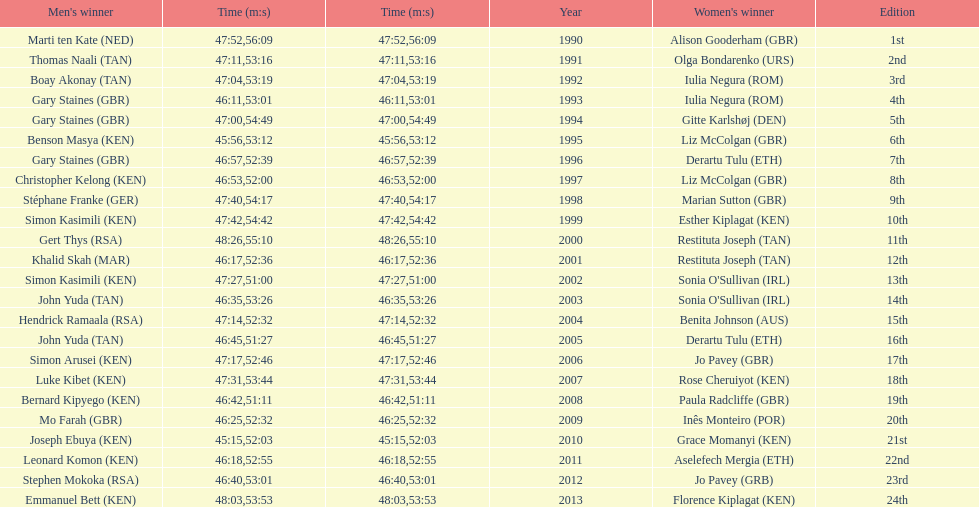Could you help me parse every detail presented in this table? {'header': ["Men's winner", 'Time (m:s)', 'Time (m:s)', 'Year', "Women's winner", 'Edition'], 'rows': [['Marti ten Kate\xa0(NED)', '47:52', '56:09', '1990', 'Alison Gooderham\xa0(GBR)', '1st'], ['Thomas Naali\xa0(TAN)', '47:11', '53:16', '1991', 'Olga Bondarenko\xa0(URS)', '2nd'], ['Boay Akonay\xa0(TAN)', '47:04', '53:19', '1992', 'Iulia Negura\xa0(ROM)', '3rd'], ['Gary Staines\xa0(GBR)', '46:11', '53:01', '1993', 'Iulia Negura\xa0(ROM)', '4th'], ['Gary Staines\xa0(GBR)', '47:00', '54:49', '1994', 'Gitte Karlshøj\xa0(DEN)', '5th'], ['Benson Masya\xa0(KEN)', '45:56', '53:12', '1995', 'Liz McColgan\xa0(GBR)', '6th'], ['Gary Staines\xa0(GBR)', '46:57', '52:39', '1996', 'Derartu Tulu\xa0(ETH)', '7th'], ['Christopher Kelong\xa0(KEN)', '46:53', '52:00', '1997', 'Liz McColgan\xa0(GBR)', '8th'], ['Stéphane Franke\xa0(GER)', '47:40', '54:17', '1998', 'Marian Sutton\xa0(GBR)', '9th'], ['Simon Kasimili\xa0(KEN)', '47:42', '54:42', '1999', 'Esther Kiplagat\xa0(KEN)', '10th'], ['Gert Thys\xa0(RSA)', '48:26', '55:10', '2000', 'Restituta Joseph\xa0(TAN)', '11th'], ['Khalid Skah\xa0(MAR)', '46:17', '52:36', '2001', 'Restituta Joseph\xa0(TAN)', '12th'], ['Simon Kasimili\xa0(KEN)', '47:27', '51:00', '2002', "Sonia O'Sullivan\xa0(IRL)", '13th'], ['John Yuda\xa0(TAN)', '46:35', '53:26', '2003', "Sonia O'Sullivan\xa0(IRL)", '14th'], ['Hendrick Ramaala\xa0(RSA)', '47:14', '52:32', '2004', 'Benita Johnson\xa0(AUS)', '15th'], ['John Yuda\xa0(TAN)', '46:45', '51:27', '2005', 'Derartu Tulu\xa0(ETH)', '16th'], ['Simon Arusei\xa0(KEN)', '47:17', '52:46', '2006', 'Jo Pavey\xa0(GBR)', '17th'], ['Luke Kibet\xa0(KEN)', '47:31', '53:44', '2007', 'Rose Cheruiyot\xa0(KEN)', '18th'], ['Bernard Kipyego\xa0(KEN)', '46:42', '51:11', '2008', 'Paula Radcliffe\xa0(GBR)', '19th'], ['Mo Farah\xa0(GBR)', '46:25', '52:32', '2009', 'Inês Monteiro\xa0(POR)', '20th'], ['Joseph Ebuya\xa0(KEN)', '45:15', '52:03', '2010', 'Grace Momanyi\xa0(KEN)', '21st'], ['Leonard Komon\xa0(KEN)', '46:18', '52:55', '2011', 'Aselefech Mergia\xa0(ETH)', '22nd'], ['Stephen Mokoka\xa0(RSA)', '46:40', '53:01', '2012', 'Jo Pavey\xa0(GRB)', '23rd'], ['Emmanuel Bett\xa0(KEN)', '48:03', '53:53', '2013', 'Florence Kiplagat\xa0(KEN)', '24th']]} Home many times did a single country win both the men's and women's bupa great south run? 4. 